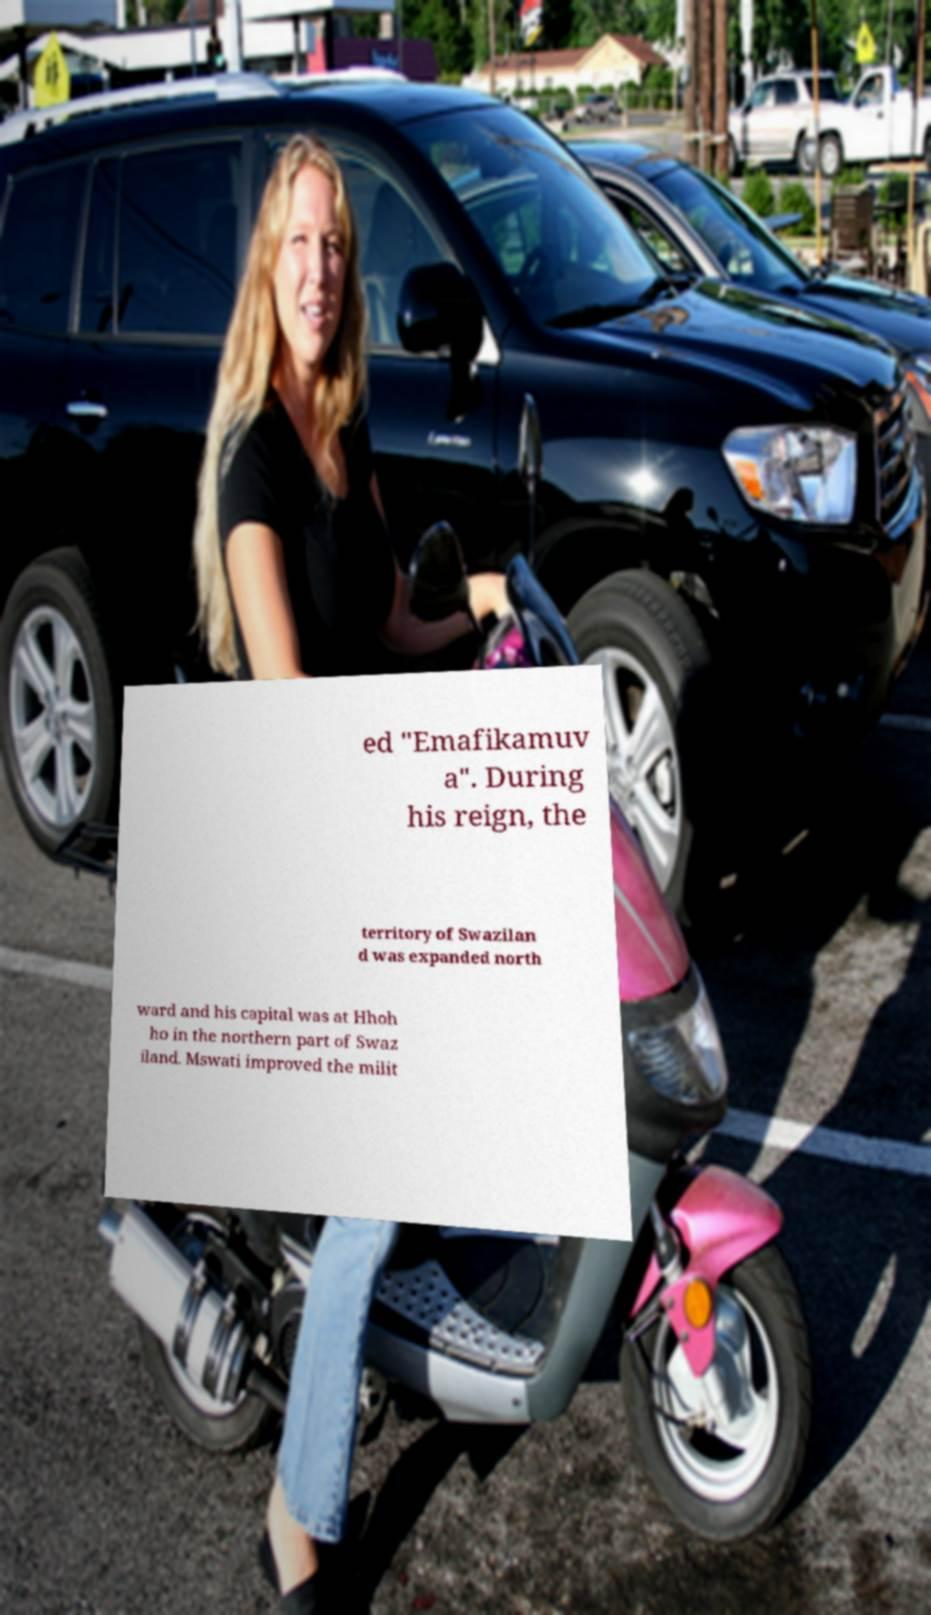What messages or text are displayed in this image? I need them in a readable, typed format. ed "Emafikamuv a". During his reign, the territory of Swazilan d was expanded north ward and his capital was at Hhoh ho in the northern part of Swaz iland. Mswati improved the milit 